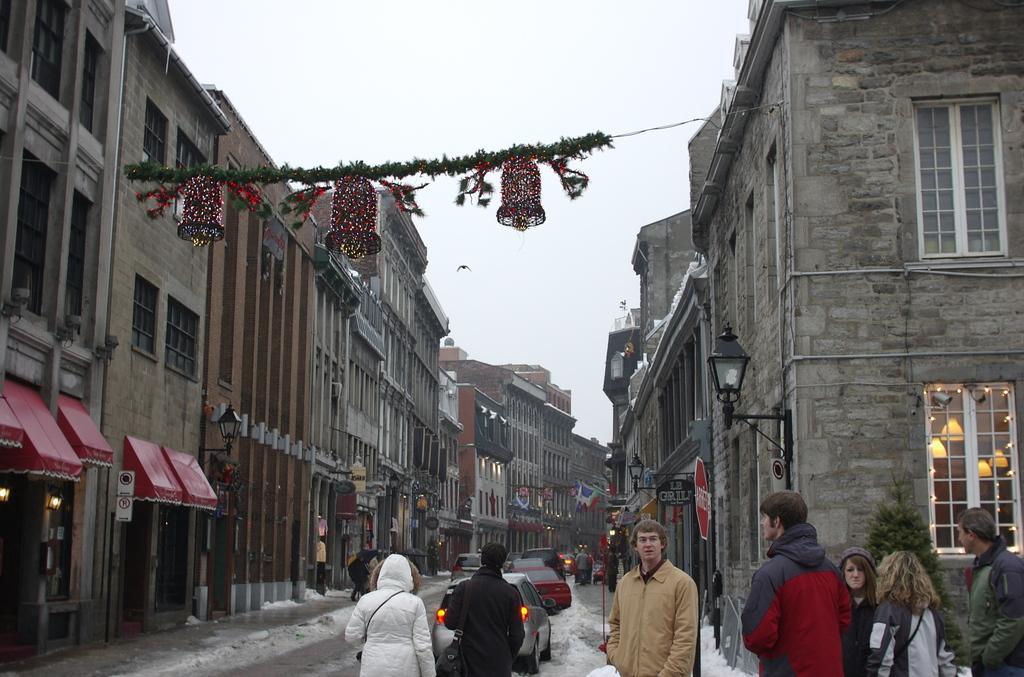How would you summarize this image in a sentence or two? In this image, we can see so many buildings, walls, windows, name boards, poles, sign board, lights. At the bottom, we can see few people, vehicles and snow. Background there is a sky. Here we can see decorative items and bells. 